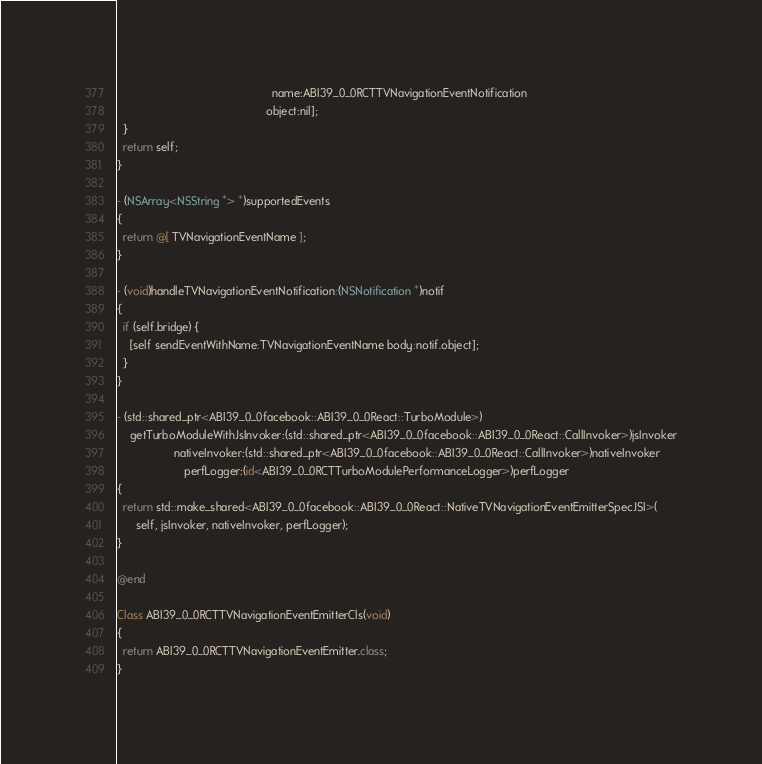<code> <loc_0><loc_0><loc_500><loc_500><_ObjectiveC_>                                                 name:ABI39_0_0RCTTVNavigationEventNotification
                                               object:nil];
  }
  return self;
}

- (NSArray<NSString *> *)supportedEvents
{
  return @[ TVNavigationEventName ];
}

- (void)handleTVNavigationEventNotification:(NSNotification *)notif
{
  if (self.bridge) {
    [self sendEventWithName:TVNavigationEventName body:notif.object];
  }
}

- (std::shared_ptr<ABI39_0_0facebook::ABI39_0_0React::TurboModule>)
    getTurboModuleWithJsInvoker:(std::shared_ptr<ABI39_0_0facebook::ABI39_0_0React::CallInvoker>)jsInvoker
                  nativeInvoker:(std::shared_ptr<ABI39_0_0facebook::ABI39_0_0React::CallInvoker>)nativeInvoker
                     perfLogger:(id<ABI39_0_0RCTTurboModulePerformanceLogger>)perfLogger
{
  return std::make_shared<ABI39_0_0facebook::ABI39_0_0React::NativeTVNavigationEventEmitterSpecJSI>(
      self, jsInvoker, nativeInvoker, perfLogger);
}

@end

Class ABI39_0_0RCTTVNavigationEventEmitterCls(void)
{
  return ABI39_0_0RCTTVNavigationEventEmitter.class;
}
</code> 